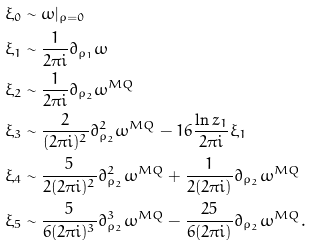Convert formula to latex. <formula><loc_0><loc_0><loc_500><loc_500>\xi _ { 0 } & \sim \omega | _ { \rho = 0 } \\ \xi _ { 1 } & \sim \frac { 1 } { 2 \pi i } \partial _ { \rho _ { 1 } } \omega \\ \xi _ { 2 } & \sim \frac { 1 } { 2 \pi i } \partial _ { \rho _ { 2 } } \omega ^ { M Q } \\ \xi _ { 3 } & \sim \frac { 2 } { ( 2 \pi i ) ^ { 2 } } \partial ^ { 2 } _ { \rho _ { 2 } } \omega ^ { M Q } - 1 6 \frac { \ln z _ { 1 } } { 2 \pi i } \xi _ { 1 } \\ \xi _ { 4 } & \sim \frac { 5 } { 2 ( 2 \pi i ) ^ { 2 } } \partial ^ { 2 } _ { \rho _ { 2 } } \omega ^ { M Q } + \frac { 1 } { 2 ( 2 \pi i ) } \partial _ { \rho _ { 2 } } \omega ^ { M Q } \\ \xi _ { 5 } & \sim \frac { 5 } { 6 ( 2 \pi i ) ^ { 3 } } \partial ^ { 3 } _ { \rho _ { 2 } } \omega ^ { M Q } - \frac { 2 5 } { 6 ( 2 \pi i ) } \partial _ { \rho _ { 2 } } \omega ^ { M Q } . \\</formula> 